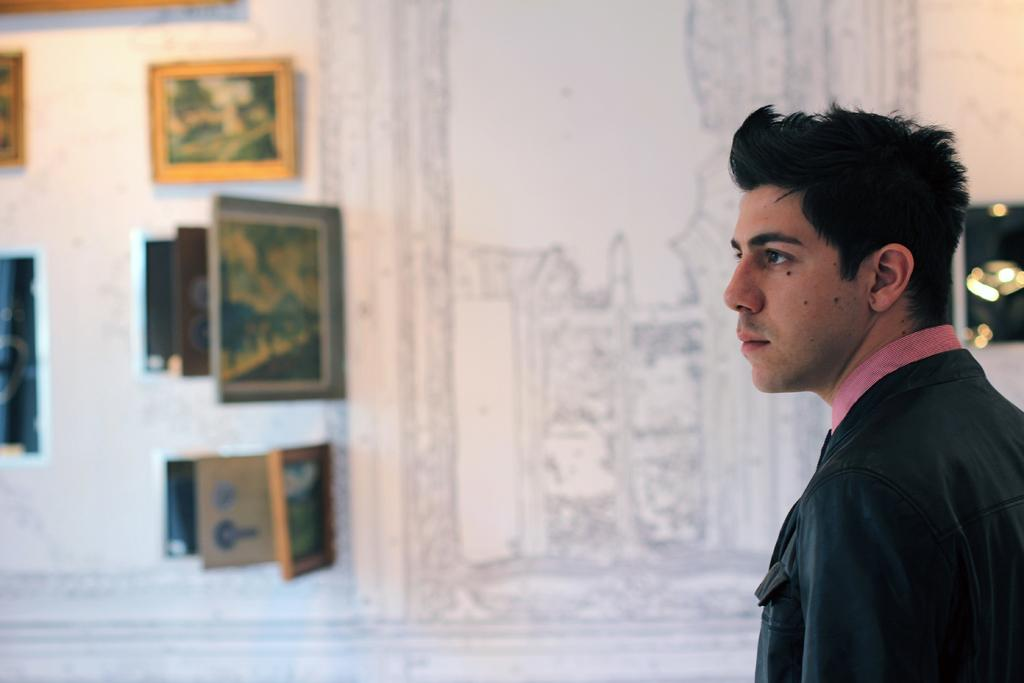What is the main subject of the image? There is a person standing in the center of the image. What can be seen in the background of the image? There is a wall in the background of the image. What is on the wall in the image? There are photo frames and some artwork on the wall. What type of lace can be seen draped over the person in the image? There is no lace present in the image; the person is not wearing or holding any lace. 